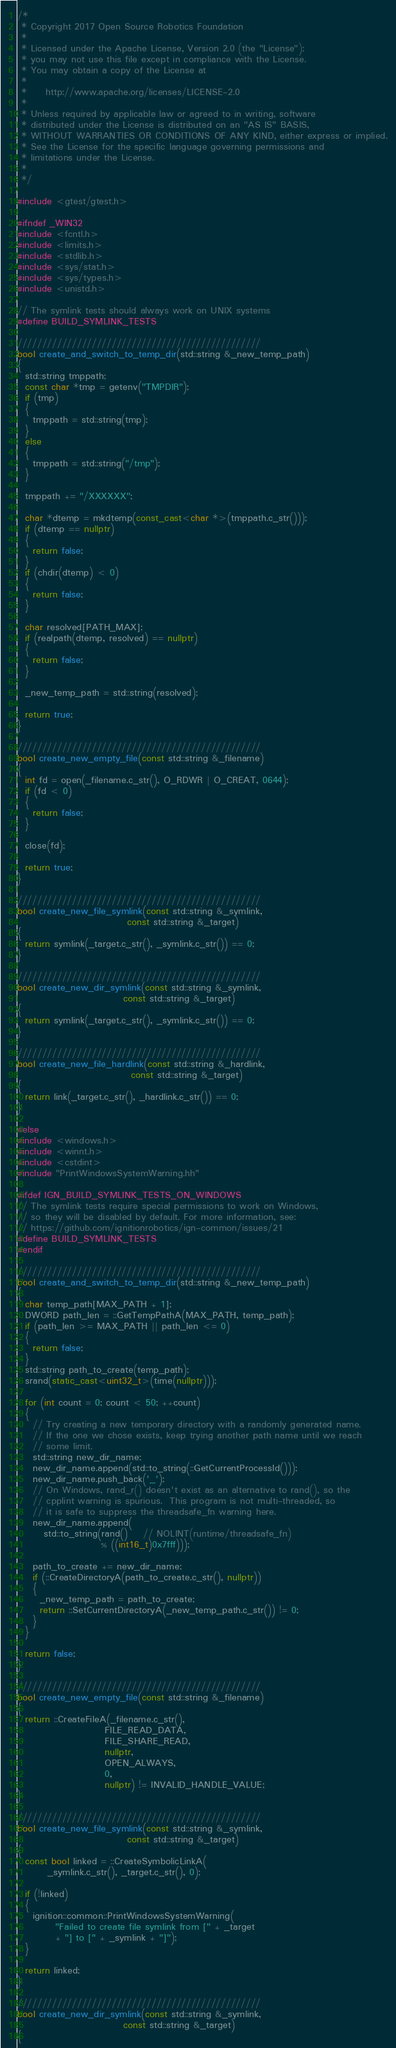<code> <loc_0><loc_0><loc_500><loc_500><_C++_>/*
 * Copyright 2017 Open Source Robotics Foundation
 *
 * Licensed under the Apache License, Version 2.0 (the "License");
 * you may not use this file except in compliance with the License.
 * You may obtain a copy of the License at
 *
 *     http://www.apache.org/licenses/LICENSE-2.0
 *
 * Unless required by applicable law or agreed to in writing, software
 * distributed under the License is distributed on an "AS IS" BASIS,
 * WITHOUT WARRANTIES OR CONDITIONS OF ANY KIND, either express or implied.
 * See the License for the specific language governing permissions and
 * limitations under the License.
 *
 */

#include <gtest/gtest.h>

#ifndef _WIN32
#include <fcntl.h>
#include <limits.h>
#include <stdlib.h>
#include <sys/stat.h>
#include <sys/types.h>
#include <unistd.h>

// The symlink tests should always work on UNIX systems
#define BUILD_SYMLINK_TESTS

/////////////////////////////////////////////////
bool create_and_switch_to_temp_dir(std::string &_new_temp_path)
{
  std::string tmppath;
  const char *tmp = getenv("TMPDIR");
  if (tmp)
  {
    tmppath = std::string(tmp);
  }
  else
  {
    tmppath = std::string("/tmp");
  }

  tmppath += "/XXXXXX";

  char *dtemp = mkdtemp(const_cast<char *>(tmppath.c_str()));
  if (dtemp == nullptr)
  {
    return false;
  }
  if (chdir(dtemp) < 0)
  {
    return false;
  }

  char resolved[PATH_MAX];
  if (realpath(dtemp, resolved) == nullptr)
  {
    return false;
  }

  _new_temp_path = std::string(resolved);

  return true;
}

/////////////////////////////////////////////////
bool create_new_empty_file(const std::string &_filename)
{
  int fd = open(_filename.c_str(), O_RDWR | O_CREAT, 0644);
  if (fd < 0)
  {
    return false;
  }

  close(fd);

  return true;
}

/////////////////////////////////////////////////
bool create_new_file_symlink(const std::string &_symlink,
                             const std::string &_target)
{
  return symlink(_target.c_str(), _symlink.c_str()) == 0;
}

/////////////////////////////////////////////////
bool create_new_dir_symlink(const std::string &_symlink,
                            const std::string &_target)
{
  return symlink(_target.c_str(), _symlink.c_str()) == 0;
}

/////////////////////////////////////////////////
bool create_new_file_hardlink(const std::string &_hardlink,
                              const std::string &_target)
{
  return link(_target.c_str(), _hardlink.c_str()) == 0;
}

#else
#include <windows.h>
#include <winnt.h>
#include <cstdint>
#include "PrintWindowsSystemWarning.hh"

#ifdef IGN_BUILD_SYMLINK_TESTS_ON_WINDOWS
// The symlink tests require special permissions to work on Windows,
// so they will be disabled by default. For more information, see:
// https://github.com/ignitionrobotics/ign-common/issues/21
#define BUILD_SYMLINK_TESTS
#endif

/////////////////////////////////////////////////
bool create_and_switch_to_temp_dir(std::string &_new_temp_path)
{
  char temp_path[MAX_PATH + 1];
  DWORD path_len = ::GetTempPathA(MAX_PATH, temp_path);
  if (path_len >= MAX_PATH || path_len <= 0)
  {
    return false;
  }
  std::string path_to_create(temp_path);
  srand(static_cast<uint32_t>(time(nullptr)));

  for (int count = 0; count < 50; ++count)
  {
    // Try creating a new temporary directory with a randomly generated name.
    // If the one we chose exists, keep trying another path name until we reach
    // some limit.
    std::string new_dir_name;
    new_dir_name.append(std::to_string(::GetCurrentProcessId()));
    new_dir_name.push_back('_');
    // On Windows, rand_r() doesn't exist as an alternative to rand(), so the
    // cpplint warning is spurious.  This program is not multi-threaded, so
    // it is safe to suppress the threadsafe_fn warning here.
    new_dir_name.append(
       std::to_string(rand()    // NOLINT(runtime/threadsafe_fn)
                      % ((int16_t)0x7fff)));

    path_to_create += new_dir_name;
    if (::CreateDirectoryA(path_to_create.c_str(), nullptr))
    {
      _new_temp_path = path_to_create;
      return ::SetCurrentDirectoryA(_new_temp_path.c_str()) != 0;
    }
  }

  return false;
}

/////////////////////////////////////////////////
bool create_new_empty_file(const std::string &_filename)
{
  return ::CreateFileA(_filename.c_str(),
                       FILE_READ_DATA,
                       FILE_SHARE_READ,
                       nullptr,
                       OPEN_ALWAYS,
                       0,
                       nullptr) != INVALID_HANDLE_VALUE;
}

/////////////////////////////////////////////////
bool create_new_file_symlink(const std::string &_symlink,
                             const std::string &_target)
{
  const bool linked = ::CreateSymbolicLinkA(
        _symlink.c_str(), _target.c_str(), 0);

  if (!linked)
  {
    ignition::common::PrintWindowsSystemWarning(
          "Failed to create file symlink from [" + _target
          + "] to [" + _symlink + "]");
  }

  return linked;
}

/////////////////////////////////////////////////
bool create_new_dir_symlink(const std::string &_symlink,
                            const std::string &_target)
{</code> 